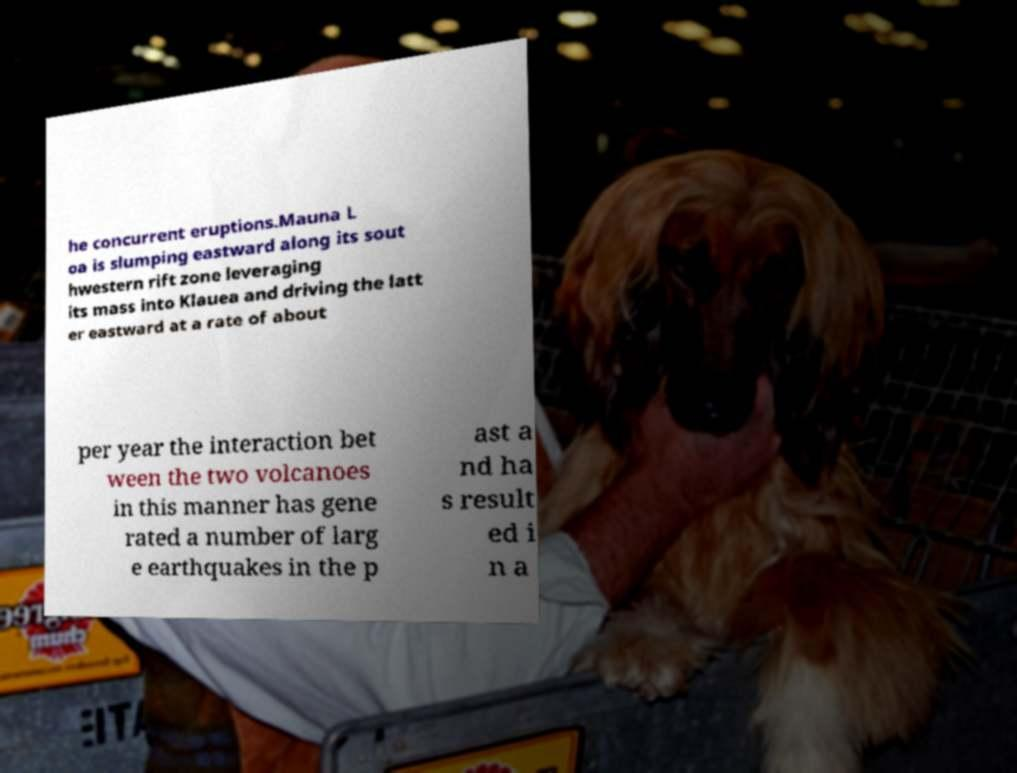Can you read and provide the text displayed in the image?This photo seems to have some interesting text. Can you extract and type it out for me? he concurrent eruptions.Mauna L oa is slumping eastward along its sout hwestern rift zone leveraging its mass into Klauea and driving the latt er eastward at a rate of about per year the interaction bet ween the two volcanoes in this manner has gene rated a number of larg e earthquakes in the p ast a nd ha s result ed i n a 